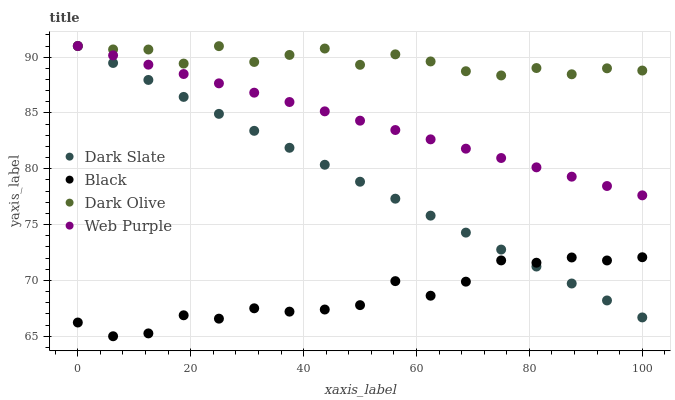Does Black have the minimum area under the curve?
Answer yes or no. Yes. Does Dark Olive have the maximum area under the curve?
Answer yes or no. Yes. Does Web Purple have the minimum area under the curve?
Answer yes or no. No. Does Web Purple have the maximum area under the curve?
Answer yes or no. No. Is Dark Slate the smoothest?
Answer yes or no. Yes. Is Black the roughest?
Answer yes or no. Yes. Is Web Purple the smoothest?
Answer yes or no. No. Is Web Purple the roughest?
Answer yes or no. No. Does Black have the lowest value?
Answer yes or no. Yes. Does Web Purple have the lowest value?
Answer yes or no. No. Does Dark Olive have the highest value?
Answer yes or no. Yes. Does Black have the highest value?
Answer yes or no. No. Is Black less than Web Purple?
Answer yes or no. Yes. Is Dark Olive greater than Black?
Answer yes or no. Yes. Does Web Purple intersect Dark Slate?
Answer yes or no. Yes. Is Web Purple less than Dark Slate?
Answer yes or no. No. Is Web Purple greater than Dark Slate?
Answer yes or no. No. Does Black intersect Web Purple?
Answer yes or no. No. 